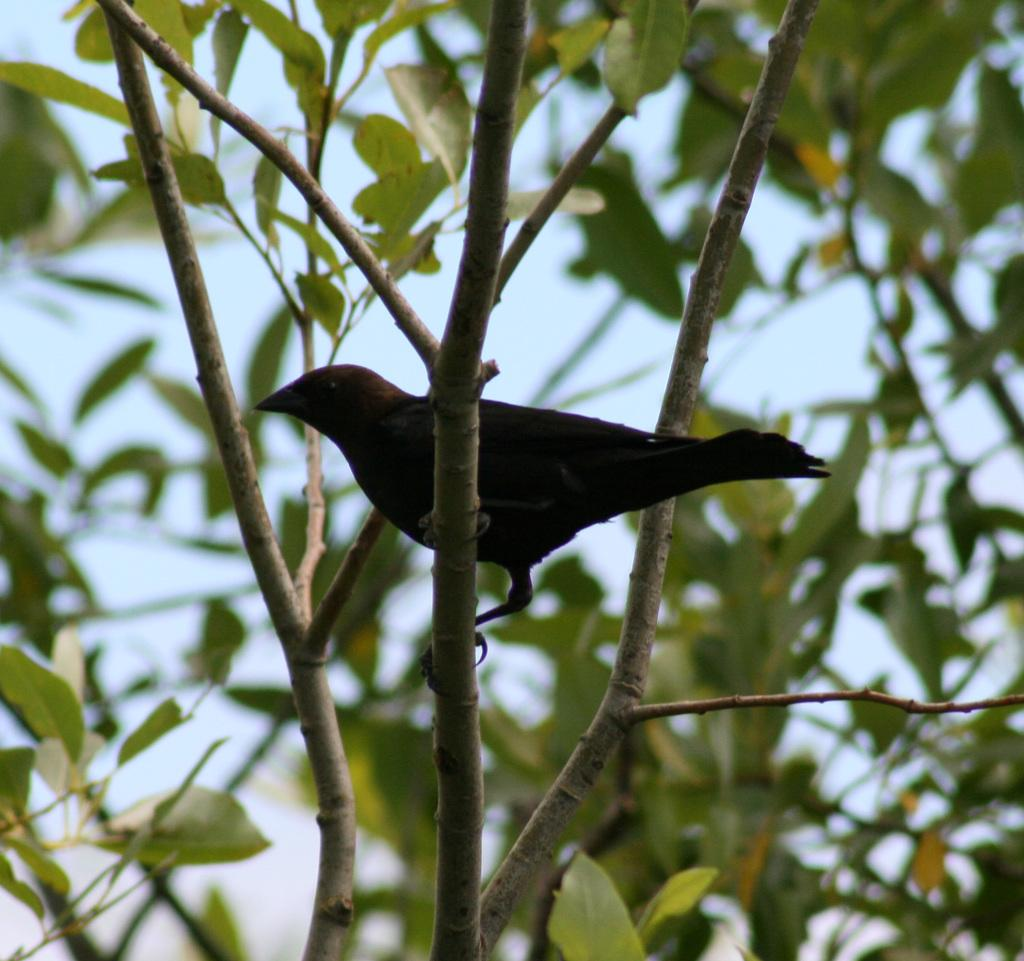What can be seen in the image that belongs to a tree? There are branches of a tree in the image. Is there any living creature present on the branches? Yes, there is a bird sitting on one of the branches. What type of request can be seen being made by the vein in the image? There is no vein present in the image, and therefore no requests can be made. 